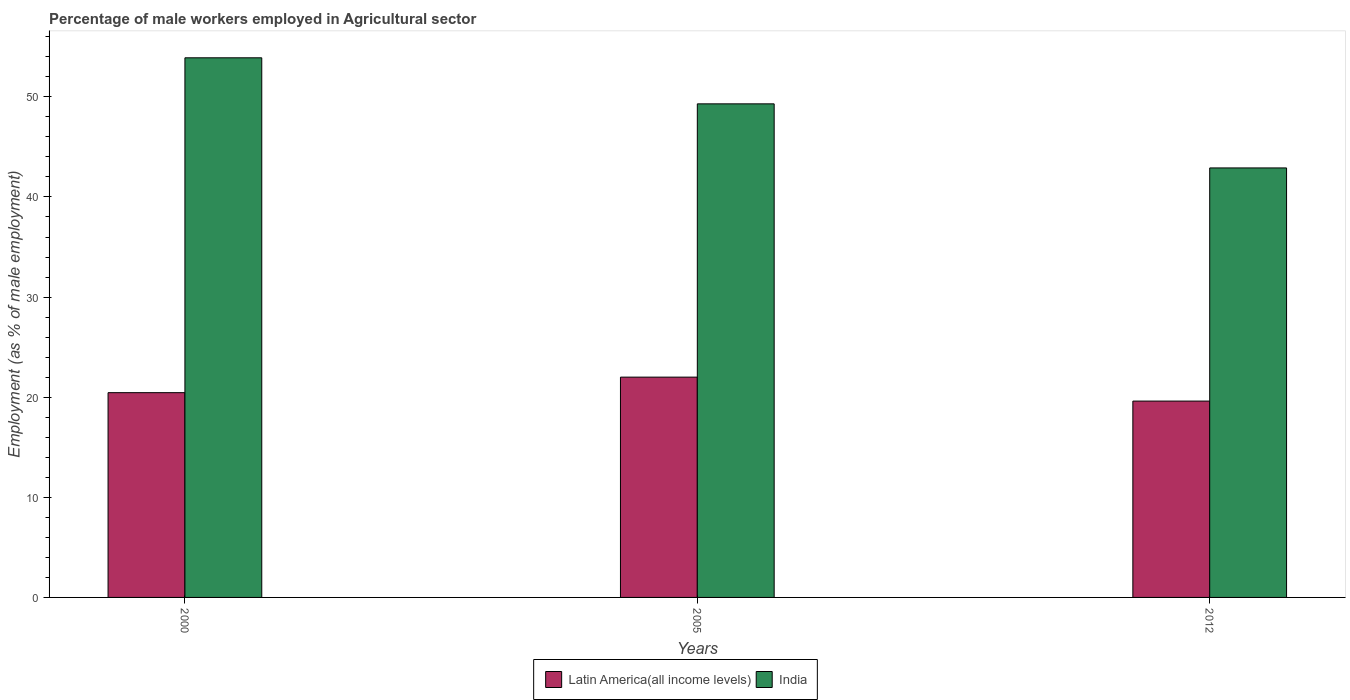How many different coloured bars are there?
Provide a succinct answer. 2. How many groups of bars are there?
Offer a very short reply. 3. Are the number of bars per tick equal to the number of legend labels?
Keep it short and to the point. Yes. How many bars are there on the 2nd tick from the left?
Keep it short and to the point. 2. What is the label of the 1st group of bars from the left?
Your answer should be very brief. 2000. What is the percentage of male workers employed in Agricultural sector in Latin America(all income levels) in 2005?
Your answer should be compact. 22. Across all years, what is the maximum percentage of male workers employed in Agricultural sector in Latin America(all income levels)?
Give a very brief answer. 22. Across all years, what is the minimum percentage of male workers employed in Agricultural sector in Latin America(all income levels)?
Ensure brevity in your answer.  19.61. In which year was the percentage of male workers employed in Agricultural sector in Latin America(all income levels) maximum?
Provide a succinct answer. 2005. In which year was the percentage of male workers employed in Agricultural sector in India minimum?
Offer a terse response. 2012. What is the total percentage of male workers employed in Agricultural sector in India in the graph?
Make the answer very short. 146.1. What is the difference between the percentage of male workers employed in Agricultural sector in India in 2000 and the percentage of male workers employed in Agricultural sector in Latin America(all income levels) in 2012?
Your answer should be very brief. 34.29. What is the average percentage of male workers employed in Agricultural sector in India per year?
Offer a terse response. 48.7. In the year 2012, what is the difference between the percentage of male workers employed in Agricultural sector in Latin America(all income levels) and percentage of male workers employed in Agricultural sector in India?
Provide a short and direct response. -23.29. In how many years, is the percentage of male workers employed in Agricultural sector in Latin America(all income levels) greater than 28 %?
Give a very brief answer. 0. What is the ratio of the percentage of male workers employed in Agricultural sector in India in 2000 to that in 2012?
Offer a very short reply. 1.26. Is the percentage of male workers employed in Agricultural sector in Latin America(all income levels) in 2000 less than that in 2012?
Ensure brevity in your answer.  No. What is the difference between the highest and the second highest percentage of male workers employed in Agricultural sector in India?
Give a very brief answer. 4.6. In how many years, is the percentage of male workers employed in Agricultural sector in Latin America(all income levels) greater than the average percentage of male workers employed in Agricultural sector in Latin America(all income levels) taken over all years?
Your answer should be very brief. 1. What does the 1st bar from the left in 2005 represents?
Your answer should be very brief. Latin America(all income levels). What does the 2nd bar from the right in 2012 represents?
Your response must be concise. Latin America(all income levels). How many years are there in the graph?
Offer a very short reply. 3. What is the difference between two consecutive major ticks on the Y-axis?
Keep it short and to the point. 10. What is the title of the graph?
Your response must be concise. Percentage of male workers employed in Agricultural sector. Does "Honduras" appear as one of the legend labels in the graph?
Give a very brief answer. No. What is the label or title of the X-axis?
Make the answer very short. Years. What is the label or title of the Y-axis?
Provide a short and direct response. Employment (as % of male employment). What is the Employment (as % of male employment) of Latin America(all income levels) in 2000?
Offer a terse response. 20.45. What is the Employment (as % of male employment) in India in 2000?
Make the answer very short. 53.9. What is the Employment (as % of male employment) of Latin America(all income levels) in 2005?
Your answer should be very brief. 22. What is the Employment (as % of male employment) of India in 2005?
Your answer should be very brief. 49.3. What is the Employment (as % of male employment) in Latin America(all income levels) in 2012?
Ensure brevity in your answer.  19.61. What is the Employment (as % of male employment) in India in 2012?
Your answer should be very brief. 42.9. Across all years, what is the maximum Employment (as % of male employment) in Latin America(all income levels)?
Your answer should be very brief. 22. Across all years, what is the maximum Employment (as % of male employment) in India?
Your answer should be very brief. 53.9. Across all years, what is the minimum Employment (as % of male employment) in Latin America(all income levels)?
Offer a very short reply. 19.61. Across all years, what is the minimum Employment (as % of male employment) in India?
Keep it short and to the point. 42.9. What is the total Employment (as % of male employment) of Latin America(all income levels) in the graph?
Ensure brevity in your answer.  62.07. What is the total Employment (as % of male employment) in India in the graph?
Provide a succinct answer. 146.1. What is the difference between the Employment (as % of male employment) in Latin America(all income levels) in 2000 and that in 2005?
Make the answer very short. -1.55. What is the difference between the Employment (as % of male employment) in Latin America(all income levels) in 2000 and that in 2012?
Keep it short and to the point. 0.84. What is the difference between the Employment (as % of male employment) in India in 2000 and that in 2012?
Give a very brief answer. 11. What is the difference between the Employment (as % of male employment) in Latin America(all income levels) in 2005 and that in 2012?
Give a very brief answer. 2.39. What is the difference between the Employment (as % of male employment) of India in 2005 and that in 2012?
Provide a short and direct response. 6.4. What is the difference between the Employment (as % of male employment) in Latin America(all income levels) in 2000 and the Employment (as % of male employment) in India in 2005?
Offer a terse response. -28.85. What is the difference between the Employment (as % of male employment) in Latin America(all income levels) in 2000 and the Employment (as % of male employment) in India in 2012?
Provide a succinct answer. -22.45. What is the difference between the Employment (as % of male employment) of Latin America(all income levels) in 2005 and the Employment (as % of male employment) of India in 2012?
Offer a very short reply. -20.9. What is the average Employment (as % of male employment) in Latin America(all income levels) per year?
Provide a short and direct response. 20.69. What is the average Employment (as % of male employment) of India per year?
Your answer should be compact. 48.7. In the year 2000, what is the difference between the Employment (as % of male employment) of Latin America(all income levels) and Employment (as % of male employment) of India?
Offer a terse response. -33.45. In the year 2005, what is the difference between the Employment (as % of male employment) in Latin America(all income levels) and Employment (as % of male employment) in India?
Ensure brevity in your answer.  -27.3. In the year 2012, what is the difference between the Employment (as % of male employment) of Latin America(all income levels) and Employment (as % of male employment) of India?
Make the answer very short. -23.29. What is the ratio of the Employment (as % of male employment) in Latin America(all income levels) in 2000 to that in 2005?
Your answer should be compact. 0.93. What is the ratio of the Employment (as % of male employment) of India in 2000 to that in 2005?
Make the answer very short. 1.09. What is the ratio of the Employment (as % of male employment) in Latin America(all income levels) in 2000 to that in 2012?
Offer a very short reply. 1.04. What is the ratio of the Employment (as % of male employment) in India in 2000 to that in 2012?
Offer a very short reply. 1.26. What is the ratio of the Employment (as % of male employment) in Latin America(all income levels) in 2005 to that in 2012?
Your answer should be very brief. 1.12. What is the ratio of the Employment (as % of male employment) in India in 2005 to that in 2012?
Your answer should be very brief. 1.15. What is the difference between the highest and the second highest Employment (as % of male employment) in Latin America(all income levels)?
Offer a very short reply. 1.55. What is the difference between the highest and the second highest Employment (as % of male employment) in India?
Keep it short and to the point. 4.6. What is the difference between the highest and the lowest Employment (as % of male employment) of Latin America(all income levels)?
Give a very brief answer. 2.39. What is the difference between the highest and the lowest Employment (as % of male employment) in India?
Provide a succinct answer. 11. 